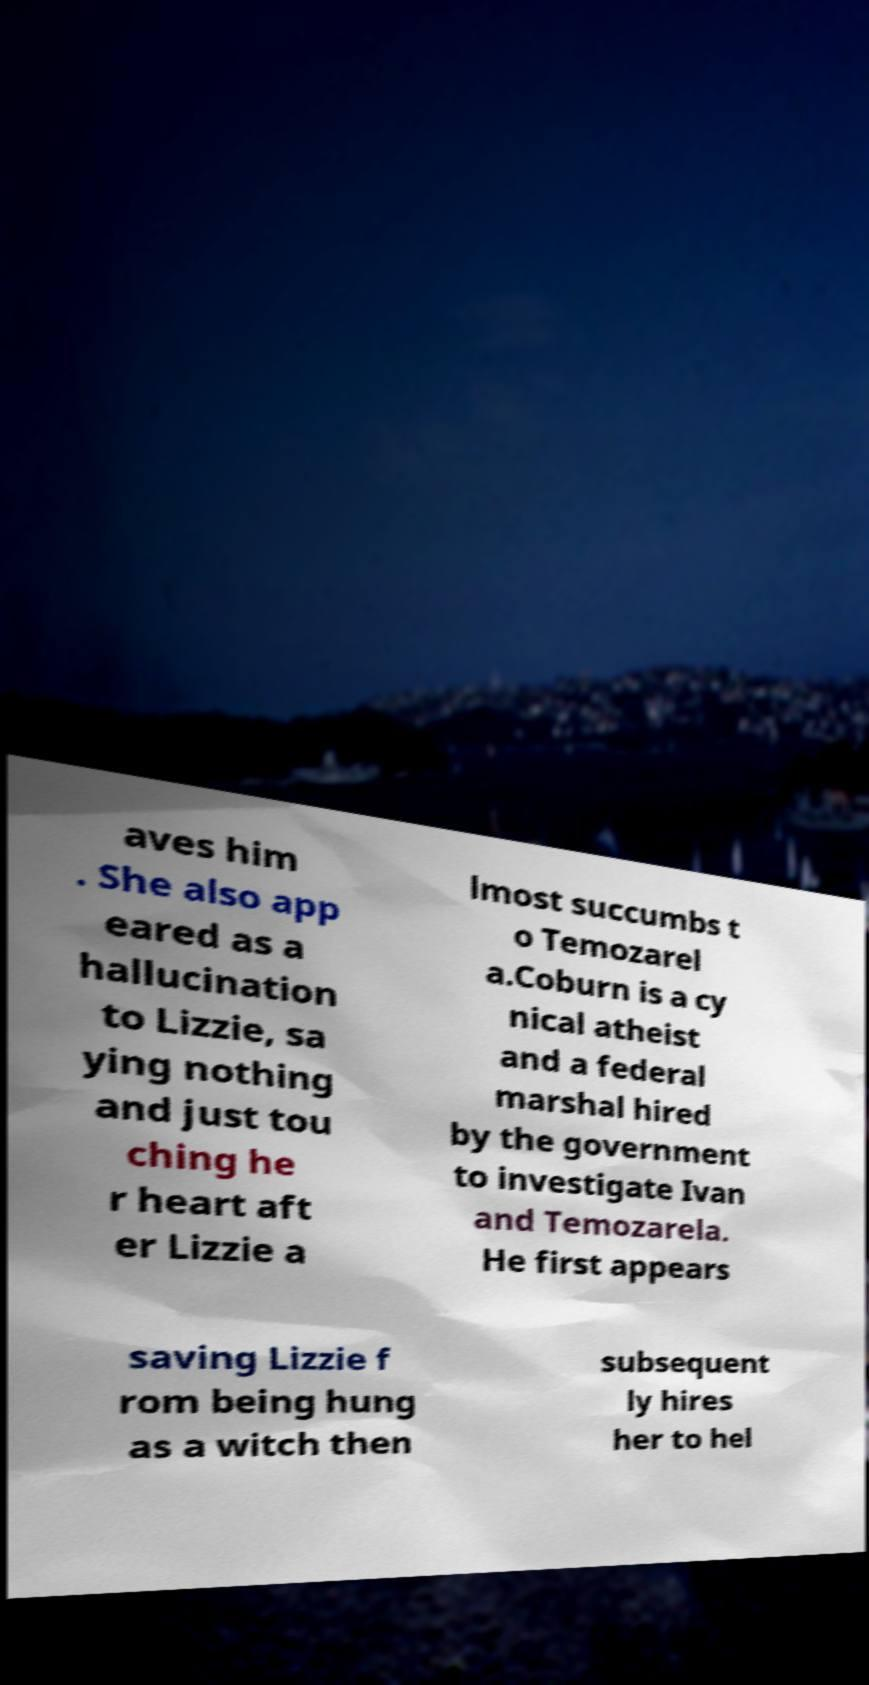Could you extract and type out the text from this image? aves him . She also app eared as a hallucination to Lizzie, sa ying nothing and just tou ching he r heart aft er Lizzie a lmost succumbs t o Temozarel a.Coburn is a cy nical atheist and a federal marshal hired by the government to investigate Ivan and Temozarela. He first appears saving Lizzie f rom being hung as a witch then subsequent ly hires her to hel 